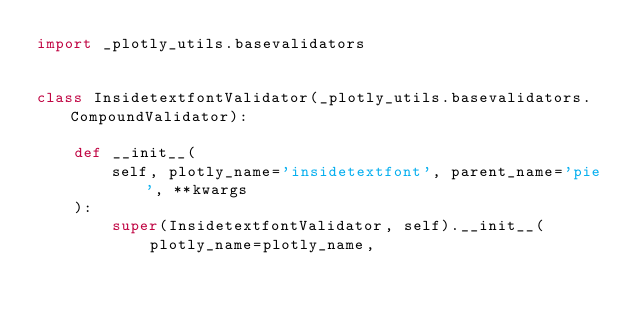Convert code to text. <code><loc_0><loc_0><loc_500><loc_500><_Python_>import _plotly_utils.basevalidators


class InsidetextfontValidator(_plotly_utils.basevalidators.CompoundValidator):

    def __init__(
        self, plotly_name='insidetextfont', parent_name='pie', **kwargs
    ):
        super(InsidetextfontValidator, self).__init__(
            plotly_name=plotly_name,</code> 